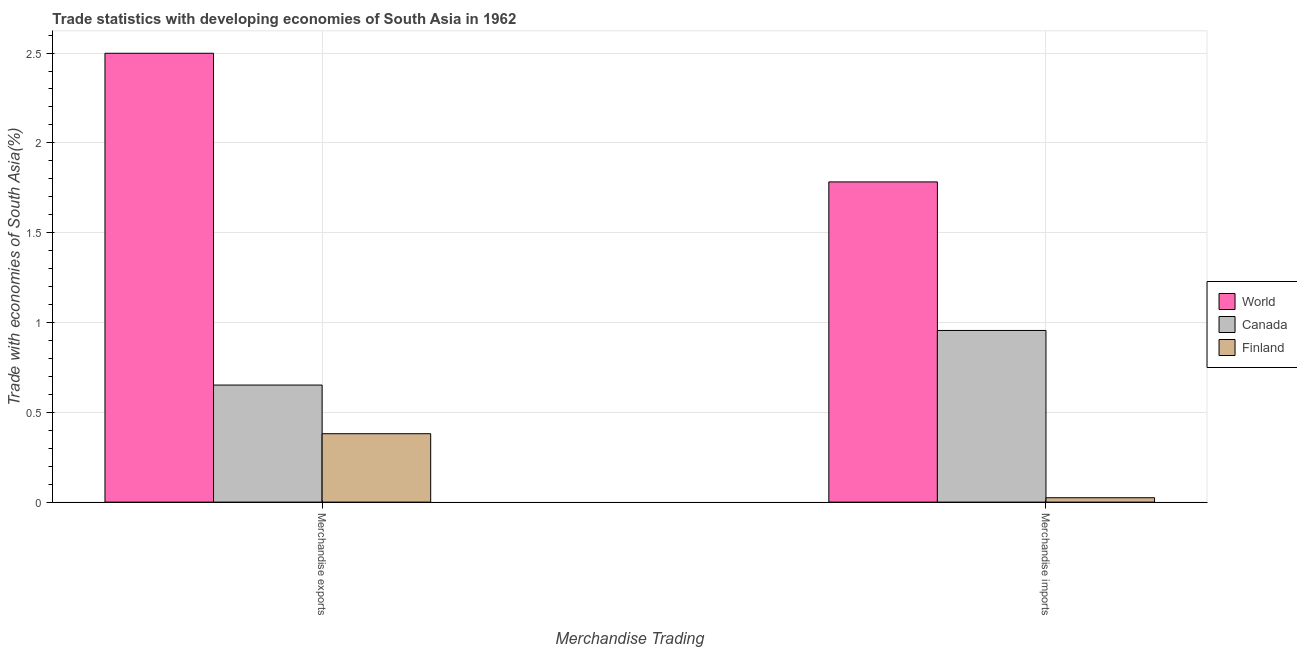How many different coloured bars are there?
Your answer should be compact. 3. How many groups of bars are there?
Your answer should be very brief. 2. Are the number of bars per tick equal to the number of legend labels?
Offer a very short reply. Yes. Are the number of bars on each tick of the X-axis equal?
Your response must be concise. Yes. How many bars are there on the 1st tick from the left?
Your answer should be compact. 3. What is the merchandise imports in Canada?
Give a very brief answer. 0.96. Across all countries, what is the maximum merchandise imports?
Keep it short and to the point. 1.78. Across all countries, what is the minimum merchandise exports?
Offer a very short reply. 0.38. In which country was the merchandise exports maximum?
Provide a short and direct response. World. What is the total merchandise imports in the graph?
Offer a terse response. 2.76. What is the difference between the merchandise imports in Finland and that in World?
Provide a succinct answer. -1.76. What is the difference between the merchandise exports in Finland and the merchandise imports in World?
Your answer should be very brief. -1.4. What is the average merchandise imports per country?
Your response must be concise. 0.92. What is the difference between the merchandise exports and merchandise imports in Finland?
Your response must be concise. 0.36. In how many countries, is the merchandise exports greater than 2.2 %?
Offer a very short reply. 1. What is the ratio of the merchandise exports in World to that in Canada?
Offer a terse response. 3.83. Is the merchandise imports in Canada less than that in Finland?
Your answer should be compact. No. In how many countries, is the merchandise exports greater than the average merchandise exports taken over all countries?
Provide a succinct answer. 1. What does the 1st bar from the left in Merchandise exports represents?
Offer a very short reply. World. What does the 2nd bar from the right in Merchandise imports represents?
Provide a short and direct response. Canada. How many bars are there?
Keep it short and to the point. 6. How many countries are there in the graph?
Ensure brevity in your answer.  3. What is the difference between two consecutive major ticks on the Y-axis?
Your response must be concise. 0.5. Does the graph contain any zero values?
Your response must be concise. No. Does the graph contain grids?
Offer a very short reply. Yes. What is the title of the graph?
Your answer should be compact. Trade statistics with developing economies of South Asia in 1962. Does "Colombia" appear as one of the legend labels in the graph?
Your response must be concise. No. What is the label or title of the X-axis?
Ensure brevity in your answer.  Merchandise Trading. What is the label or title of the Y-axis?
Offer a terse response. Trade with economies of South Asia(%). What is the Trade with economies of South Asia(%) of World in Merchandise exports?
Ensure brevity in your answer.  2.5. What is the Trade with economies of South Asia(%) of Canada in Merchandise exports?
Offer a very short reply. 0.65. What is the Trade with economies of South Asia(%) in Finland in Merchandise exports?
Offer a terse response. 0.38. What is the Trade with economies of South Asia(%) in World in Merchandise imports?
Your answer should be compact. 1.78. What is the Trade with economies of South Asia(%) in Canada in Merchandise imports?
Offer a very short reply. 0.96. What is the Trade with economies of South Asia(%) in Finland in Merchandise imports?
Give a very brief answer. 0.02. Across all Merchandise Trading, what is the maximum Trade with economies of South Asia(%) in World?
Provide a succinct answer. 2.5. Across all Merchandise Trading, what is the maximum Trade with economies of South Asia(%) in Canada?
Keep it short and to the point. 0.96. Across all Merchandise Trading, what is the maximum Trade with economies of South Asia(%) of Finland?
Provide a short and direct response. 0.38. Across all Merchandise Trading, what is the minimum Trade with economies of South Asia(%) of World?
Keep it short and to the point. 1.78. Across all Merchandise Trading, what is the minimum Trade with economies of South Asia(%) of Canada?
Your answer should be very brief. 0.65. Across all Merchandise Trading, what is the minimum Trade with economies of South Asia(%) of Finland?
Ensure brevity in your answer.  0.02. What is the total Trade with economies of South Asia(%) of World in the graph?
Your answer should be compact. 4.28. What is the total Trade with economies of South Asia(%) in Canada in the graph?
Ensure brevity in your answer.  1.61. What is the total Trade with economies of South Asia(%) of Finland in the graph?
Ensure brevity in your answer.  0.41. What is the difference between the Trade with economies of South Asia(%) in World in Merchandise exports and that in Merchandise imports?
Your answer should be compact. 0.72. What is the difference between the Trade with economies of South Asia(%) of Canada in Merchandise exports and that in Merchandise imports?
Offer a terse response. -0.3. What is the difference between the Trade with economies of South Asia(%) of Finland in Merchandise exports and that in Merchandise imports?
Your answer should be compact. 0.36. What is the difference between the Trade with economies of South Asia(%) of World in Merchandise exports and the Trade with economies of South Asia(%) of Canada in Merchandise imports?
Offer a very short reply. 1.54. What is the difference between the Trade with economies of South Asia(%) in World in Merchandise exports and the Trade with economies of South Asia(%) in Finland in Merchandise imports?
Your response must be concise. 2.47. What is the difference between the Trade with economies of South Asia(%) in Canada in Merchandise exports and the Trade with economies of South Asia(%) in Finland in Merchandise imports?
Give a very brief answer. 0.63. What is the average Trade with economies of South Asia(%) of World per Merchandise Trading?
Make the answer very short. 2.14. What is the average Trade with economies of South Asia(%) in Canada per Merchandise Trading?
Give a very brief answer. 0.8. What is the average Trade with economies of South Asia(%) of Finland per Merchandise Trading?
Offer a very short reply. 0.2. What is the difference between the Trade with economies of South Asia(%) in World and Trade with economies of South Asia(%) in Canada in Merchandise exports?
Your answer should be compact. 1.85. What is the difference between the Trade with economies of South Asia(%) of World and Trade with economies of South Asia(%) of Finland in Merchandise exports?
Provide a short and direct response. 2.12. What is the difference between the Trade with economies of South Asia(%) of Canada and Trade with economies of South Asia(%) of Finland in Merchandise exports?
Ensure brevity in your answer.  0.27. What is the difference between the Trade with economies of South Asia(%) in World and Trade with economies of South Asia(%) in Canada in Merchandise imports?
Your answer should be compact. 0.83. What is the difference between the Trade with economies of South Asia(%) of World and Trade with economies of South Asia(%) of Finland in Merchandise imports?
Provide a succinct answer. 1.76. What is the difference between the Trade with economies of South Asia(%) of Canada and Trade with economies of South Asia(%) of Finland in Merchandise imports?
Make the answer very short. 0.93. What is the ratio of the Trade with economies of South Asia(%) of World in Merchandise exports to that in Merchandise imports?
Your answer should be compact. 1.4. What is the ratio of the Trade with economies of South Asia(%) of Canada in Merchandise exports to that in Merchandise imports?
Ensure brevity in your answer.  0.68. What is the ratio of the Trade with economies of South Asia(%) of Finland in Merchandise exports to that in Merchandise imports?
Ensure brevity in your answer.  15.59. What is the difference between the highest and the second highest Trade with economies of South Asia(%) of World?
Make the answer very short. 0.72. What is the difference between the highest and the second highest Trade with economies of South Asia(%) of Canada?
Ensure brevity in your answer.  0.3. What is the difference between the highest and the second highest Trade with economies of South Asia(%) in Finland?
Make the answer very short. 0.36. What is the difference between the highest and the lowest Trade with economies of South Asia(%) in World?
Keep it short and to the point. 0.72. What is the difference between the highest and the lowest Trade with economies of South Asia(%) in Canada?
Keep it short and to the point. 0.3. What is the difference between the highest and the lowest Trade with economies of South Asia(%) in Finland?
Keep it short and to the point. 0.36. 